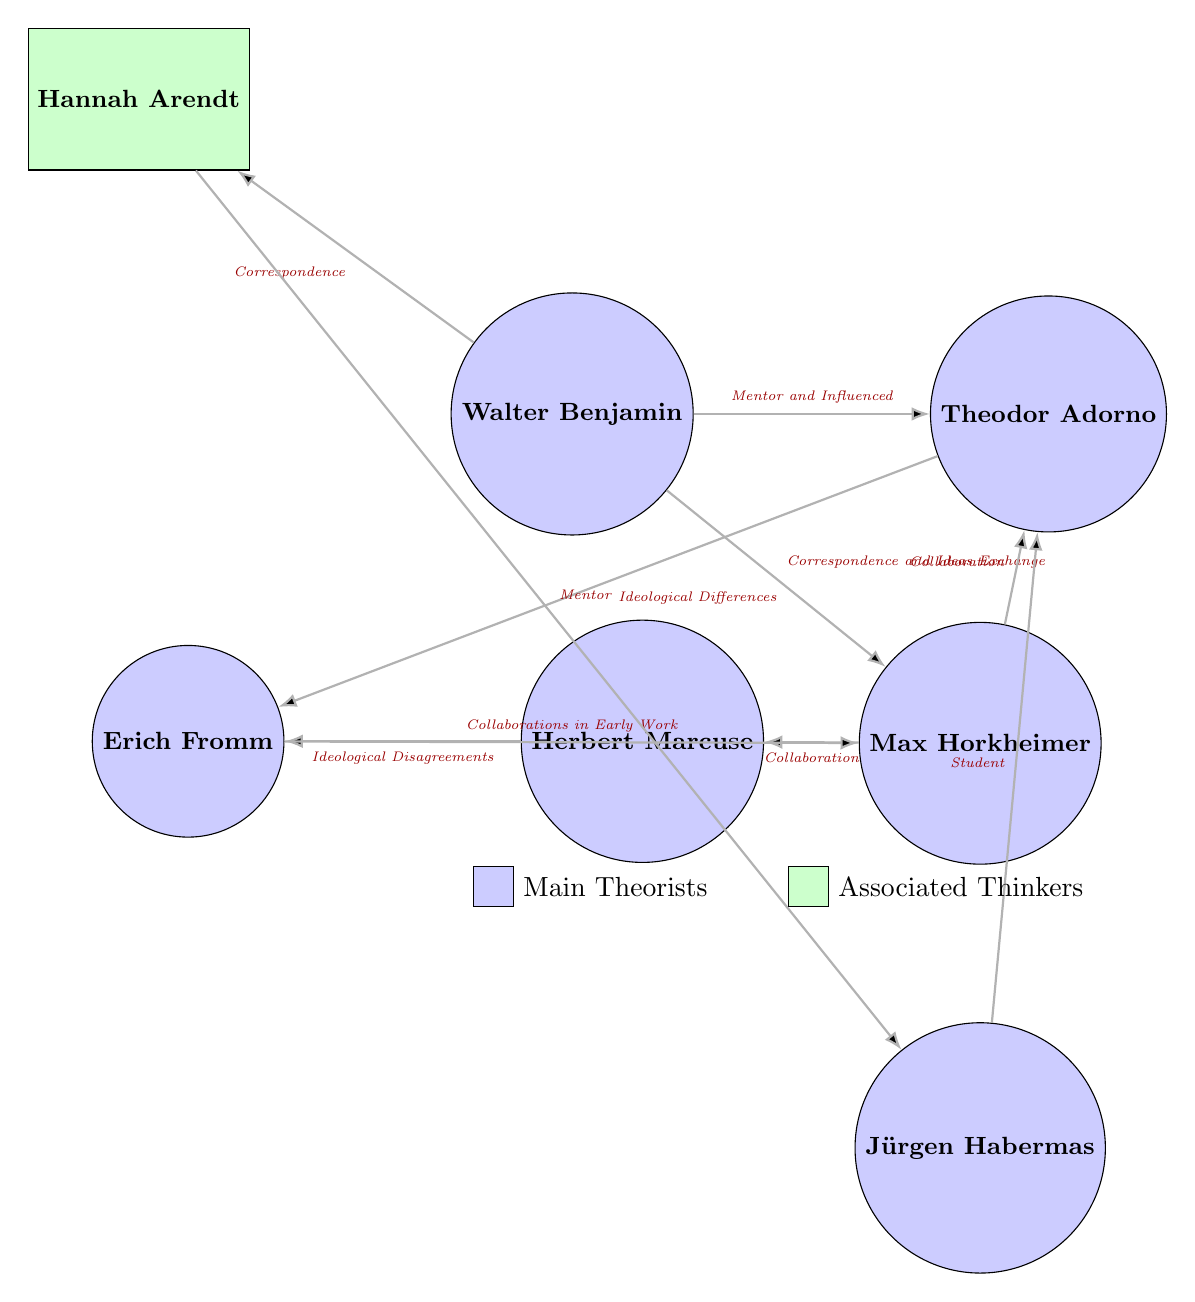What is the role of Hannah Arendt in relation to Walter Benjamin? The diagram indicates a connection labeled "Correspondence" between Walter Benjamin and Hannah Arendt, signifying that they engaged in written communication. Additionally, Arendt is positioned as a mentor to Jürgen Habermas further down, suggesting that her intellectual influence extends beyond just Benjamin's correspondence.
Answer: Correspondence How many theorists are connected to Max Horkheimer? In the diagram, Max Horkheimer has connections to three theorists: Walter Benjamin, Theodor Adorno, and Herbert Marcuse, represented by the lines leading from Horkheimer to each of them.
Answer: 3 What kind of relationship exists between Herbert Marcuse and Erich Fromm? The diagram shows a connection labeled "Ideological Disagreements" pointing from Herbert Marcuse to Erich Fromm, indicating a specific type of relationship characterized by differing ideological views.
Answer: Ideological Disagreements Who is shown to have influenced Theodor Adorno? The visual indicates that Walter Benjamin is represented as Adorno's mentor, denoted by the connection labeled "Mentor and Influenced," which highlights Benjamin's role in shaping Adorno’s thoughts.
Answer: Walter Benjamin How many associated thinkers are present in the diagram? The diagram includes one associated thinker, Hannah Arendt, represented by the rectangle filled with green color, indicating her classification as an associated thinker rather than a main theorist.
Answer: 1 What type of collaboration is depicted between Max Horkheimer and Theodor Adorno? The connection labeled "Collaboration" between Max Horkheimer and Theodor Adorno suggests a collective effort or joint work in their intellectual pursuits.
Answer: Collaboration Identify the theorist who is connected to both Walter Benjamin and Jürgen Habermas. The diagram shows Hannah Arendt connected with Walter Benjamin via "Correspondence" and also positioned as a mentor to Jürgen Habermas, illustrating her pivotal role between these two theorists.
Answer: Hannah Arendt Which theorist is directly identified as a student of Theodor Adorno? The diagram clearly labels Jürgen Habermas as a student of Theodor Adorno, as shown by the direct connection labeled "Student" pointing from Habermas to Adorno.
Answer: Jürgen Habermas How are Herbert Marcuse and Max Horkheimer connected? In the diagram, the connection labeled "Collaboration" illustrates that they worked together, denoting a shared intellectual synergy or partnership in their theoretical explorations.
Answer: Collaboration 